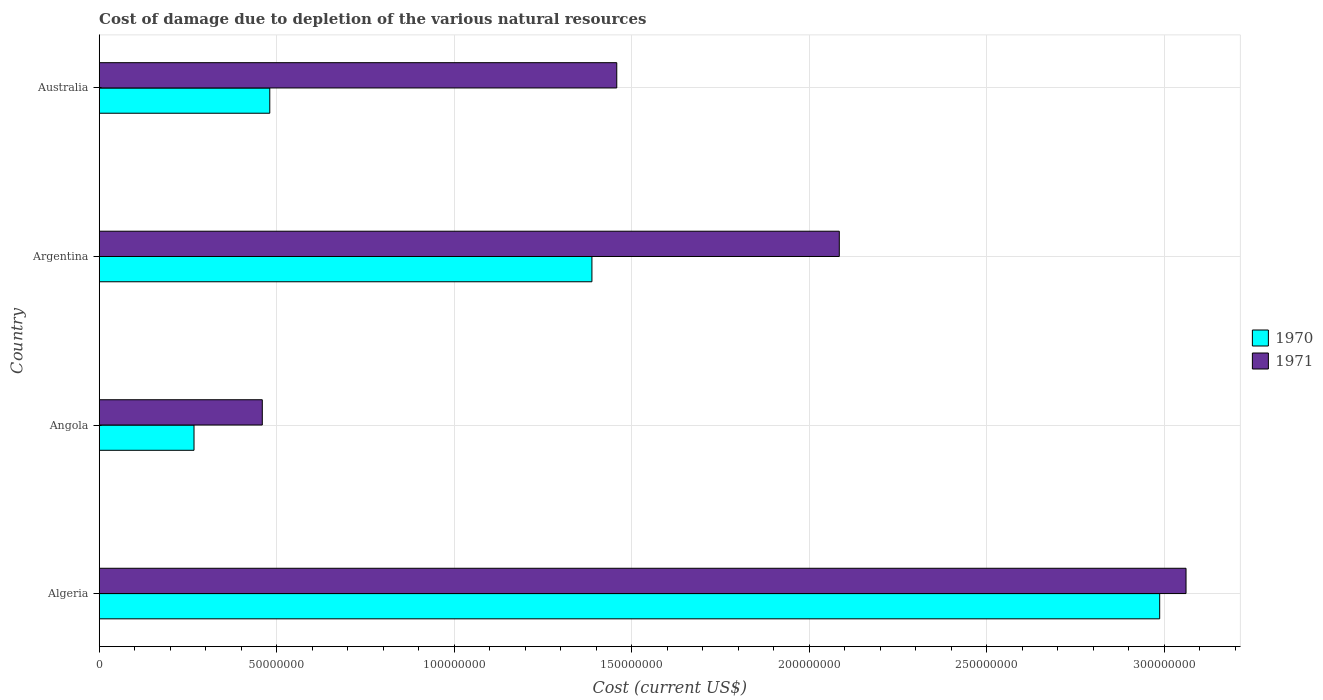How many different coloured bars are there?
Keep it short and to the point. 2. Are the number of bars on each tick of the Y-axis equal?
Offer a terse response. Yes. How many bars are there on the 1st tick from the top?
Make the answer very short. 2. What is the label of the 2nd group of bars from the top?
Your answer should be compact. Argentina. What is the cost of damage caused due to the depletion of various natural resources in 1970 in Algeria?
Your answer should be compact. 2.99e+08. Across all countries, what is the maximum cost of damage caused due to the depletion of various natural resources in 1970?
Provide a succinct answer. 2.99e+08. Across all countries, what is the minimum cost of damage caused due to the depletion of various natural resources in 1971?
Your answer should be very brief. 4.59e+07. In which country was the cost of damage caused due to the depletion of various natural resources in 1971 maximum?
Offer a very short reply. Algeria. In which country was the cost of damage caused due to the depletion of various natural resources in 1970 minimum?
Your answer should be very brief. Angola. What is the total cost of damage caused due to the depletion of various natural resources in 1971 in the graph?
Provide a succinct answer. 7.06e+08. What is the difference between the cost of damage caused due to the depletion of various natural resources in 1970 in Algeria and that in Argentina?
Your answer should be compact. 1.60e+08. What is the difference between the cost of damage caused due to the depletion of various natural resources in 1971 in Angola and the cost of damage caused due to the depletion of various natural resources in 1970 in Algeria?
Ensure brevity in your answer.  -2.53e+08. What is the average cost of damage caused due to the depletion of various natural resources in 1971 per country?
Keep it short and to the point. 1.77e+08. What is the difference between the cost of damage caused due to the depletion of various natural resources in 1971 and cost of damage caused due to the depletion of various natural resources in 1970 in Argentina?
Offer a very short reply. 6.97e+07. In how many countries, is the cost of damage caused due to the depletion of various natural resources in 1970 greater than 230000000 US$?
Give a very brief answer. 1. What is the ratio of the cost of damage caused due to the depletion of various natural resources in 1971 in Angola to that in Argentina?
Your response must be concise. 0.22. Is the cost of damage caused due to the depletion of various natural resources in 1971 in Algeria less than that in Angola?
Provide a succinct answer. No. Is the difference between the cost of damage caused due to the depletion of various natural resources in 1971 in Argentina and Australia greater than the difference between the cost of damage caused due to the depletion of various natural resources in 1970 in Argentina and Australia?
Provide a short and direct response. No. What is the difference between the highest and the second highest cost of damage caused due to the depletion of various natural resources in 1970?
Offer a very short reply. 1.60e+08. What is the difference between the highest and the lowest cost of damage caused due to the depletion of various natural resources in 1970?
Offer a terse response. 2.72e+08. In how many countries, is the cost of damage caused due to the depletion of various natural resources in 1970 greater than the average cost of damage caused due to the depletion of various natural resources in 1970 taken over all countries?
Provide a succinct answer. 2. Does the graph contain any zero values?
Your response must be concise. No. Does the graph contain grids?
Offer a very short reply. Yes. What is the title of the graph?
Your response must be concise. Cost of damage due to depletion of the various natural resources. Does "2009" appear as one of the legend labels in the graph?
Your answer should be very brief. No. What is the label or title of the X-axis?
Your answer should be compact. Cost (current US$). What is the label or title of the Y-axis?
Provide a short and direct response. Country. What is the Cost (current US$) of 1970 in Algeria?
Provide a short and direct response. 2.99e+08. What is the Cost (current US$) of 1971 in Algeria?
Your answer should be very brief. 3.06e+08. What is the Cost (current US$) of 1970 in Angola?
Keep it short and to the point. 2.67e+07. What is the Cost (current US$) of 1971 in Angola?
Give a very brief answer. 4.59e+07. What is the Cost (current US$) of 1970 in Argentina?
Provide a short and direct response. 1.39e+08. What is the Cost (current US$) in 1971 in Argentina?
Your answer should be compact. 2.08e+08. What is the Cost (current US$) of 1970 in Australia?
Your answer should be compact. 4.80e+07. What is the Cost (current US$) in 1971 in Australia?
Offer a terse response. 1.46e+08. Across all countries, what is the maximum Cost (current US$) in 1970?
Your answer should be compact. 2.99e+08. Across all countries, what is the maximum Cost (current US$) in 1971?
Provide a short and direct response. 3.06e+08. Across all countries, what is the minimum Cost (current US$) of 1970?
Keep it short and to the point. 2.67e+07. Across all countries, what is the minimum Cost (current US$) in 1971?
Offer a terse response. 4.59e+07. What is the total Cost (current US$) in 1970 in the graph?
Make the answer very short. 5.12e+08. What is the total Cost (current US$) of 1971 in the graph?
Keep it short and to the point. 7.06e+08. What is the difference between the Cost (current US$) of 1970 in Algeria and that in Angola?
Keep it short and to the point. 2.72e+08. What is the difference between the Cost (current US$) of 1971 in Algeria and that in Angola?
Your answer should be very brief. 2.60e+08. What is the difference between the Cost (current US$) in 1970 in Algeria and that in Argentina?
Provide a succinct answer. 1.60e+08. What is the difference between the Cost (current US$) in 1971 in Algeria and that in Argentina?
Give a very brief answer. 9.77e+07. What is the difference between the Cost (current US$) of 1970 in Algeria and that in Australia?
Provide a short and direct response. 2.51e+08. What is the difference between the Cost (current US$) in 1971 in Algeria and that in Australia?
Ensure brevity in your answer.  1.60e+08. What is the difference between the Cost (current US$) in 1970 in Angola and that in Argentina?
Provide a succinct answer. -1.12e+08. What is the difference between the Cost (current US$) in 1971 in Angola and that in Argentina?
Give a very brief answer. -1.62e+08. What is the difference between the Cost (current US$) of 1970 in Angola and that in Australia?
Ensure brevity in your answer.  -2.13e+07. What is the difference between the Cost (current US$) in 1971 in Angola and that in Australia?
Provide a short and direct response. -9.98e+07. What is the difference between the Cost (current US$) of 1970 in Argentina and that in Australia?
Your answer should be very brief. 9.07e+07. What is the difference between the Cost (current US$) in 1971 in Argentina and that in Australia?
Your response must be concise. 6.27e+07. What is the difference between the Cost (current US$) in 1970 in Algeria and the Cost (current US$) in 1971 in Angola?
Your answer should be compact. 2.53e+08. What is the difference between the Cost (current US$) in 1970 in Algeria and the Cost (current US$) in 1971 in Argentina?
Keep it short and to the point. 9.02e+07. What is the difference between the Cost (current US$) of 1970 in Algeria and the Cost (current US$) of 1971 in Australia?
Your response must be concise. 1.53e+08. What is the difference between the Cost (current US$) of 1970 in Angola and the Cost (current US$) of 1971 in Argentina?
Provide a short and direct response. -1.82e+08. What is the difference between the Cost (current US$) in 1970 in Angola and the Cost (current US$) in 1971 in Australia?
Offer a very short reply. -1.19e+08. What is the difference between the Cost (current US$) of 1970 in Argentina and the Cost (current US$) of 1971 in Australia?
Ensure brevity in your answer.  -7.00e+06. What is the average Cost (current US$) in 1970 per country?
Provide a succinct answer. 1.28e+08. What is the average Cost (current US$) of 1971 per country?
Offer a terse response. 1.77e+08. What is the difference between the Cost (current US$) in 1970 and Cost (current US$) in 1971 in Algeria?
Offer a terse response. -7.42e+06. What is the difference between the Cost (current US$) in 1970 and Cost (current US$) in 1971 in Angola?
Ensure brevity in your answer.  -1.92e+07. What is the difference between the Cost (current US$) of 1970 and Cost (current US$) of 1971 in Argentina?
Ensure brevity in your answer.  -6.97e+07. What is the difference between the Cost (current US$) in 1970 and Cost (current US$) in 1971 in Australia?
Give a very brief answer. -9.77e+07. What is the ratio of the Cost (current US$) in 1970 in Algeria to that in Angola?
Give a very brief answer. 11.19. What is the ratio of the Cost (current US$) of 1971 in Algeria to that in Angola?
Give a very brief answer. 6.66. What is the ratio of the Cost (current US$) of 1970 in Algeria to that in Argentina?
Your answer should be very brief. 2.15. What is the ratio of the Cost (current US$) in 1971 in Algeria to that in Argentina?
Make the answer very short. 1.47. What is the ratio of the Cost (current US$) of 1970 in Algeria to that in Australia?
Offer a terse response. 6.22. What is the ratio of the Cost (current US$) of 1971 in Algeria to that in Australia?
Ensure brevity in your answer.  2.1. What is the ratio of the Cost (current US$) in 1970 in Angola to that in Argentina?
Your answer should be very brief. 0.19. What is the ratio of the Cost (current US$) of 1971 in Angola to that in Argentina?
Ensure brevity in your answer.  0.22. What is the ratio of the Cost (current US$) in 1970 in Angola to that in Australia?
Keep it short and to the point. 0.56. What is the ratio of the Cost (current US$) of 1971 in Angola to that in Australia?
Your answer should be compact. 0.32. What is the ratio of the Cost (current US$) in 1970 in Argentina to that in Australia?
Make the answer very short. 2.89. What is the ratio of the Cost (current US$) of 1971 in Argentina to that in Australia?
Your answer should be compact. 1.43. What is the difference between the highest and the second highest Cost (current US$) in 1970?
Provide a short and direct response. 1.60e+08. What is the difference between the highest and the second highest Cost (current US$) of 1971?
Provide a short and direct response. 9.77e+07. What is the difference between the highest and the lowest Cost (current US$) of 1970?
Your answer should be very brief. 2.72e+08. What is the difference between the highest and the lowest Cost (current US$) of 1971?
Ensure brevity in your answer.  2.60e+08. 